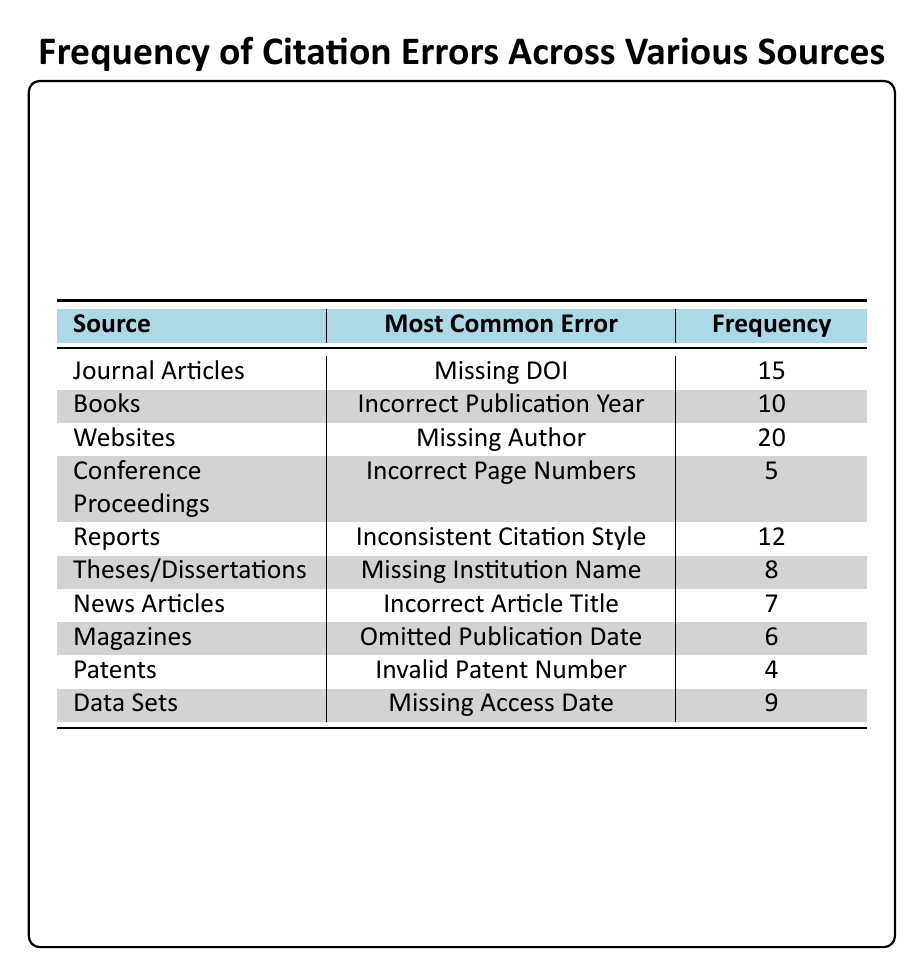What is the most common error in Websites? According to the table, the most common error in Websites is "Missing Author," which is listed in the second column for the Websites source.
Answer: Missing Author How many errors are reported for Journal Articles? The frequency of errors reported for Journal Articles, as seen in the table, is listed as 15 in the frequency column.
Answer: 15 Which source has the least frequency of citation errors? By reviewing the frequency values across all sources, Patents have the lowest frequency of errors at 4. This can be determined by comparing the frequency values in the table.
Answer: 4 What is the total frequency of citation errors for Books and Data Sets combined? Adding the frequency values for Books (10) and Data Sets (9) gives a total frequency of 10 + 9 = 19. This operation involves summing the respective frequencies.
Answer: 19 Is there a source with the error "Invalid Patent Number"? The table indicates that "Invalid Patent Number" is listed under the source Patents, which confirms that there is indeed a source with this error.
Answer: Yes Which error type has a frequency greater than 10? From the table, the errors with a frequency greater than 10 are "Missing Author" from Websites (20), "Missing DOI" from Journal Articles (15), and "Inconsistent Citation Style" from Reports (12). Reviewing the frequency values allows us to single these out.
Answer: Missing Author, Missing DOI, Inconsistent Citation Style How many sources report errors related to missing information? The sources reporting errors related to missing information include Journal Articles (Missing DOI), Websites (Missing Author), Theses/Dissertations (Missing Institution Name), and Data Sets (Missing Access Date). This amounts to a total of four sources, which can be verified by listing only those sources with relevant errors.
Answer: 4 What is the average frequency of errors for sources where the frequency is greater than 5? The valid sources and their frequencies greater than 5 are: Journal Articles (15), Books (10), Websites (20), Reports (12), Theses/Dissertations (8), News Articles (7), and Data Sets (9). This totals to 7 sources with a combined frequency of 15 + 10 + 20 + 12 + 8 + 7 + 9 = 91. To find the average, we divide by 7, which gives us 91/7 = approximately 13. The calculations involve summing those frequencies and then dividing by the number of valid sources.
Answer: Approximately 13 What percentage of the errors are attributed to Websites? The frequency of errors from Websites is 20, and the total frequency of errors from all sources is 91. To find the percentage attributed to Websites: (20 / 91) * 100 = approximately 21.98%. Calculating this percentage requires both the frequency of Websites and the total frequency to derive the final result.
Answer: Approximately 21.98% 